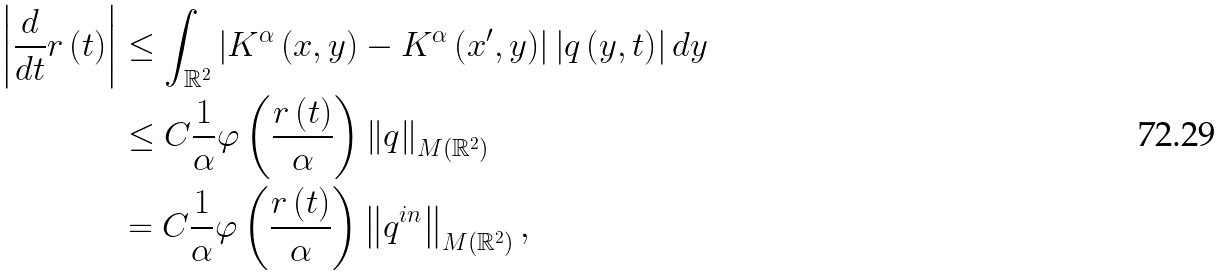Convert formula to latex. <formula><loc_0><loc_0><loc_500><loc_500>\left | \frac { d } { d t } r \left ( t \right ) \right | & \leq \int _ { \mathbb { R } ^ { 2 } } \left | K ^ { \alpha } \left ( x , y \right ) - K ^ { \alpha } \left ( x ^ { \prime } , y \right ) \right | \left | q \left ( y , t \right ) \right | d y \\ & \leq C \frac { 1 } { \alpha } \varphi \left ( \frac { r \left ( t \right ) } { \alpha } \right ) \left \| q \right \| _ { M \left ( \mathbb { R } ^ { 2 } \right ) } \\ & = C \frac { 1 } { \alpha } \varphi \left ( \frac { r \left ( t \right ) } { \alpha } \right ) \left \| q ^ { i n } \right \| _ { M \left ( \mathbb { R } ^ { 2 } \right ) } ,</formula> 